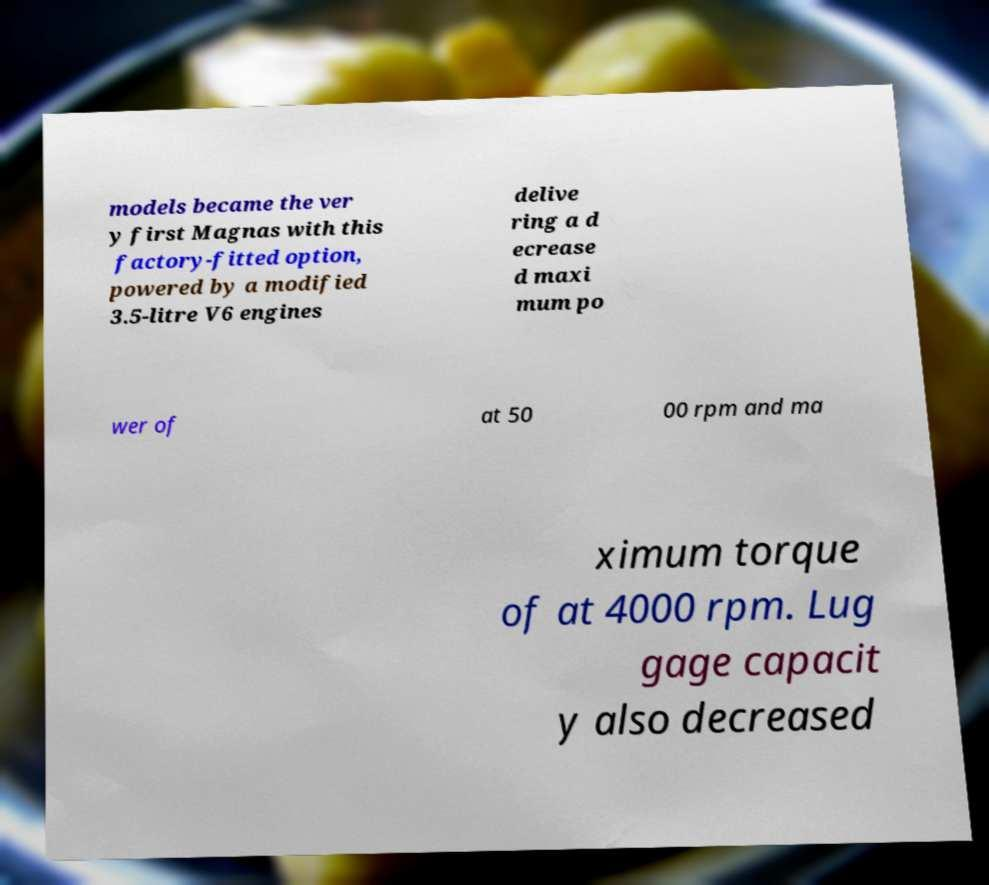Can you accurately transcribe the text from the provided image for me? models became the ver y first Magnas with this factory-fitted option, powered by a modified 3.5-litre V6 engines delive ring a d ecrease d maxi mum po wer of at 50 00 rpm and ma ximum torque of at 4000 rpm. Lug gage capacit y also decreased 